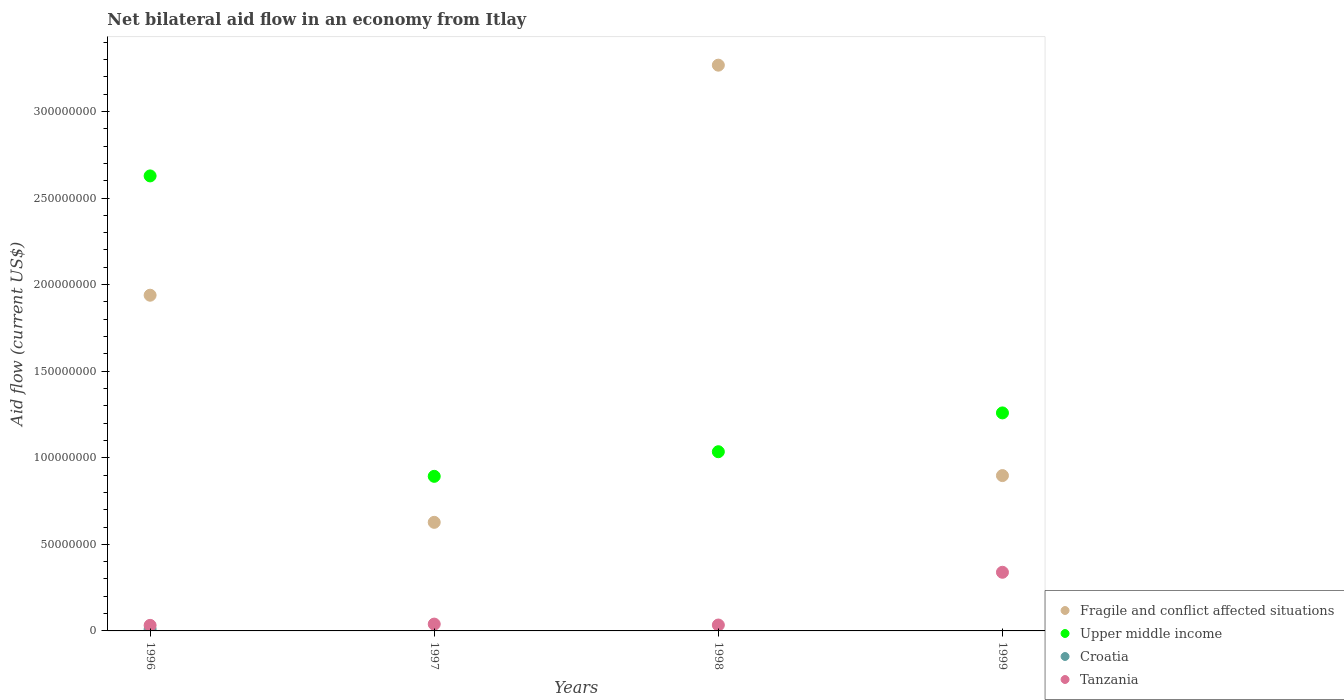What is the net bilateral aid flow in Fragile and conflict affected situations in 1999?
Your response must be concise. 8.97e+07. Across all years, what is the maximum net bilateral aid flow in Upper middle income?
Provide a succinct answer. 2.63e+08. Across all years, what is the minimum net bilateral aid flow in Upper middle income?
Ensure brevity in your answer.  8.93e+07. What is the total net bilateral aid flow in Upper middle income in the graph?
Offer a terse response. 5.81e+08. What is the difference between the net bilateral aid flow in Fragile and conflict affected situations in 1996 and that in 1997?
Your answer should be very brief. 1.31e+08. What is the difference between the net bilateral aid flow in Tanzania in 1998 and the net bilateral aid flow in Upper middle income in 1997?
Offer a terse response. -8.59e+07. What is the average net bilateral aid flow in Fragile and conflict affected situations per year?
Provide a short and direct response. 1.68e+08. In the year 1998, what is the difference between the net bilateral aid flow in Upper middle income and net bilateral aid flow in Tanzania?
Ensure brevity in your answer.  1.00e+08. In how many years, is the net bilateral aid flow in Fragile and conflict affected situations greater than 170000000 US$?
Keep it short and to the point. 2. What is the ratio of the net bilateral aid flow in Fragile and conflict affected situations in 1998 to that in 1999?
Your response must be concise. 3.64. What is the difference between the highest and the second highest net bilateral aid flow in Upper middle income?
Offer a terse response. 1.37e+08. What is the difference between the highest and the lowest net bilateral aid flow in Croatia?
Keep it short and to the point. 9.80e+05. Is the net bilateral aid flow in Tanzania strictly greater than the net bilateral aid flow in Fragile and conflict affected situations over the years?
Provide a succinct answer. No. Is the net bilateral aid flow in Croatia strictly less than the net bilateral aid flow in Tanzania over the years?
Your response must be concise. Yes. How many dotlines are there?
Give a very brief answer. 4. How many years are there in the graph?
Give a very brief answer. 4. What is the difference between two consecutive major ticks on the Y-axis?
Provide a short and direct response. 5.00e+07. Does the graph contain grids?
Your response must be concise. No. How are the legend labels stacked?
Give a very brief answer. Vertical. What is the title of the graph?
Keep it short and to the point. Net bilateral aid flow in an economy from Itlay. Does "United States" appear as one of the legend labels in the graph?
Offer a very short reply. No. What is the label or title of the Y-axis?
Give a very brief answer. Aid flow (current US$). What is the Aid flow (current US$) in Fragile and conflict affected situations in 1996?
Make the answer very short. 1.94e+08. What is the Aid flow (current US$) in Upper middle income in 1996?
Your response must be concise. 2.63e+08. What is the Aid flow (current US$) in Croatia in 1996?
Make the answer very short. 9.80e+05. What is the Aid flow (current US$) in Tanzania in 1996?
Make the answer very short. 3.21e+06. What is the Aid flow (current US$) in Fragile and conflict affected situations in 1997?
Offer a very short reply. 6.27e+07. What is the Aid flow (current US$) of Upper middle income in 1997?
Provide a short and direct response. 8.93e+07. What is the Aid flow (current US$) in Croatia in 1997?
Your answer should be very brief. 0. What is the Aid flow (current US$) of Tanzania in 1997?
Your answer should be very brief. 3.94e+06. What is the Aid flow (current US$) of Fragile and conflict affected situations in 1998?
Keep it short and to the point. 3.27e+08. What is the Aid flow (current US$) in Upper middle income in 1998?
Offer a very short reply. 1.03e+08. What is the Aid flow (current US$) of Tanzania in 1998?
Ensure brevity in your answer.  3.41e+06. What is the Aid flow (current US$) in Fragile and conflict affected situations in 1999?
Your answer should be very brief. 8.97e+07. What is the Aid flow (current US$) of Upper middle income in 1999?
Keep it short and to the point. 1.26e+08. What is the Aid flow (current US$) in Tanzania in 1999?
Offer a very short reply. 3.39e+07. Across all years, what is the maximum Aid flow (current US$) in Fragile and conflict affected situations?
Your answer should be very brief. 3.27e+08. Across all years, what is the maximum Aid flow (current US$) of Upper middle income?
Provide a short and direct response. 2.63e+08. Across all years, what is the maximum Aid flow (current US$) in Croatia?
Your response must be concise. 9.80e+05. Across all years, what is the maximum Aid flow (current US$) of Tanzania?
Make the answer very short. 3.39e+07. Across all years, what is the minimum Aid flow (current US$) of Fragile and conflict affected situations?
Provide a short and direct response. 6.27e+07. Across all years, what is the minimum Aid flow (current US$) of Upper middle income?
Your answer should be compact. 8.93e+07. Across all years, what is the minimum Aid flow (current US$) in Croatia?
Your response must be concise. 0. Across all years, what is the minimum Aid flow (current US$) of Tanzania?
Offer a terse response. 3.21e+06. What is the total Aid flow (current US$) in Fragile and conflict affected situations in the graph?
Ensure brevity in your answer.  6.73e+08. What is the total Aid flow (current US$) of Upper middle income in the graph?
Ensure brevity in your answer.  5.81e+08. What is the total Aid flow (current US$) in Croatia in the graph?
Ensure brevity in your answer.  9.80e+05. What is the total Aid flow (current US$) of Tanzania in the graph?
Provide a succinct answer. 4.44e+07. What is the difference between the Aid flow (current US$) of Fragile and conflict affected situations in 1996 and that in 1997?
Provide a succinct answer. 1.31e+08. What is the difference between the Aid flow (current US$) in Upper middle income in 1996 and that in 1997?
Your answer should be very brief. 1.74e+08. What is the difference between the Aid flow (current US$) of Tanzania in 1996 and that in 1997?
Provide a succinct answer. -7.30e+05. What is the difference between the Aid flow (current US$) of Fragile and conflict affected situations in 1996 and that in 1998?
Provide a succinct answer. -1.33e+08. What is the difference between the Aid flow (current US$) in Upper middle income in 1996 and that in 1998?
Make the answer very short. 1.59e+08. What is the difference between the Aid flow (current US$) in Fragile and conflict affected situations in 1996 and that in 1999?
Your answer should be compact. 1.04e+08. What is the difference between the Aid flow (current US$) in Upper middle income in 1996 and that in 1999?
Your response must be concise. 1.37e+08. What is the difference between the Aid flow (current US$) in Tanzania in 1996 and that in 1999?
Offer a very short reply. -3.07e+07. What is the difference between the Aid flow (current US$) of Fragile and conflict affected situations in 1997 and that in 1998?
Your answer should be very brief. -2.64e+08. What is the difference between the Aid flow (current US$) in Upper middle income in 1997 and that in 1998?
Give a very brief answer. -1.42e+07. What is the difference between the Aid flow (current US$) of Tanzania in 1997 and that in 1998?
Keep it short and to the point. 5.30e+05. What is the difference between the Aid flow (current US$) in Fragile and conflict affected situations in 1997 and that in 1999?
Provide a succinct answer. -2.70e+07. What is the difference between the Aid flow (current US$) of Upper middle income in 1997 and that in 1999?
Make the answer very short. -3.66e+07. What is the difference between the Aid flow (current US$) of Tanzania in 1997 and that in 1999?
Your response must be concise. -2.99e+07. What is the difference between the Aid flow (current US$) of Fragile and conflict affected situations in 1998 and that in 1999?
Make the answer very short. 2.37e+08. What is the difference between the Aid flow (current US$) in Upper middle income in 1998 and that in 1999?
Offer a terse response. -2.24e+07. What is the difference between the Aid flow (current US$) in Tanzania in 1998 and that in 1999?
Make the answer very short. -3.05e+07. What is the difference between the Aid flow (current US$) in Fragile and conflict affected situations in 1996 and the Aid flow (current US$) in Upper middle income in 1997?
Provide a short and direct response. 1.05e+08. What is the difference between the Aid flow (current US$) of Fragile and conflict affected situations in 1996 and the Aid flow (current US$) of Tanzania in 1997?
Provide a short and direct response. 1.90e+08. What is the difference between the Aid flow (current US$) in Upper middle income in 1996 and the Aid flow (current US$) in Tanzania in 1997?
Make the answer very short. 2.59e+08. What is the difference between the Aid flow (current US$) in Croatia in 1996 and the Aid flow (current US$) in Tanzania in 1997?
Ensure brevity in your answer.  -2.96e+06. What is the difference between the Aid flow (current US$) of Fragile and conflict affected situations in 1996 and the Aid flow (current US$) of Upper middle income in 1998?
Provide a succinct answer. 9.04e+07. What is the difference between the Aid flow (current US$) of Fragile and conflict affected situations in 1996 and the Aid flow (current US$) of Tanzania in 1998?
Your response must be concise. 1.90e+08. What is the difference between the Aid flow (current US$) of Upper middle income in 1996 and the Aid flow (current US$) of Tanzania in 1998?
Keep it short and to the point. 2.59e+08. What is the difference between the Aid flow (current US$) of Croatia in 1996 and the Aid flow (current US$) of Tanzania in 1998?
Provide a short and direct response. -2.43e+06. What is the difference between the Aid flow (current US$) in Fragile and conflict affected situations in 1996 and the Aid flow (current US$) in Upper middle income in 1999?
Your response must be concise. 6.80e+07. What is the difference between the Aid flow (current US$) of Fragile and conflict affected situations in 1996 and the Aid flow (current US$) of Tanzania in 1999?
Your answer should be compact. 1.60e+08. What is the difference between the Aid flow (current US$) in Upper middle income in 1996 and the Aid flow (current US$) in Tanzania in 1999?
Keep it short and to the point. 2.29e+08. What is the difference between the Aid flow (current US$) in Croatia in 1996 and the Aid flow (current US$) in Tanzania in 1999?
Your response must be concise. -3.29e+07. What is the difference between the Aid flow (current US$) in Fragile and conflict affected situations in 1997 and the Aid flow (current US$) in Upper middle income in 1998?
Your answer should be compact. -4.08e+07. What is the difference between the Aid flow (current US$) in Fragile and conflict affected situations in 1997 and the Aid flow (current US$) in Tanzania in 1998?
Your answer should be very brief. 5.93e+07. What is the difference between the Aid flow (current US$) in Upper middle income in 1997 and the Aid flow (current US$) in Tanzania in 1998?
Make the answer very short. 8.59e+07. What is the difference between the Aid flow (current US$) in Fragile and conflict affected situations in 1997 and the Aid flow (current US$) in Upper middle income in 1999?
Offer a very short reply. -6.32e+07. What is the difference between the Aid flow (current US$) in Fragile and conflict affected situations in 1997 and the Aid flow (current US$) in Tanzania in 1999?
Keep it short and to the point. 2.88e+07. What is the difference between the Aid flow (current US$) of Upper middle income in 1997 and the Aid flow (current US$) of Tanzania in 1999?
Give a very brief answer. 5.54e+07. What is the difference between the Aid flow (current US$) in Fragile and conflict affected situations in 1998 and the Aid flow (current US$) in Upper middle income in 1999?
Give a very brief answer. 2.01e+08. What is the difference between the Aid flow (current US$) of Fragile and conflict affected situations in 1998 and the Aid flow (current US$) of Tanzania in 1999?
Keep it short and to the point. 2.93e+08. What is the difference between the Aid flow (current US$) in Upper middle income in 1998 and the Aid flow (current US$) in Tanzania in 1999?
Offer a terse response. 6.96e+07. What is the average Aid flow (current US$) of Fragile and conflict affected situations per year?
Your answer should be compact. 1.68e+08. What is the average Aid flow (current US$) of Upper middle income per year?
Offer a terse response. 1.45e+08. What is the average Aid flow (current US$) of Croatia per year?
Keep it short and to the point. 2.45e+05. What is the average Aid flow (current US$) of Tanzania per year?
Ensure brevity in your answer.  1.11e+07. In the year 1996, what is the difference between the Aid flow (current US$) of Fragile and conflict affected situations and Aid flow (current US$) of Upper middle income?
Provide a succinct answer. -6.89e+07. In the year 1996, what is the difference between the Aid flow (current US$) of Fragile and conflict affected situations and Aid flow (current US$) of Croatia?
Give a very brief answer. 1.93e+08. In the year 1996, what is the difference between the Aid flow (current US$) in Fragile and conflict affected situations and Aid flow (current US$) in Tanzania?
Offer a terse response. 1.91e+08. In the year 1996, what is the difference between the Aid flow (current US$) of Upper middle income and Aid flow (current US$) of Croatia?
Your answer should be compact. 2.62e+08. In the year 1996, what is the difference between the Aid flow (current US$) of Upper middle income and Aid flow (current US$) of Tanzania?
Offer a very short reply. 2.60e+08. In the year 1996, what is the difference between the Aid flow (current US$) of Croatia and Aid flow (current US$) of Tanzania?
Your answer should be compact. -2.23e+06. In the year 1997, what is the difference between the Aid flow (current US$) of Fragile and conflict affected situations and Aid flow (current US$) of Upper middle income?
Provide a short and direct response. -2.66e+07. In the year 1997, what is the difference between the Aid flow (current US$) of Fragile and conflict affected situations and Aid flow (current US$) of Tanzania?
Provide a short and direct response. 5.88e+07. In the year 1997, what is the difference between the Aid flow (current US$) in Upper middle income and Aid flow (current US$) in Tanzania?
Your response must be concise. 8.53e+07. In the year 1998, what is the difference between the Aid flow (current US$) of Fragile and conflict affected situations and Aid flow (current US$) of Upper middle income?
Provide a succinct answer. 2.23e+08. In the year 1998, what is the difference between the Aid flow (current US$) in Fragile and conflict affected situations and Aid flow (current US$) in Tanzania?
Keep it short and to the point. 3.23e+08. In the year 1998, what is the difference between the Aid flow (current US$) of Upper middle income and Aid flow (current US$) of Tanzania?
Offer a terse response. 1.00e+08. In the year 1999, what is the difference between the Aid flow (current US$) in Fragile and conflict affected situations and Aid flow (current US$) in Upper middle income?
Offer a terse response. -3.62e+07. In the year 1999, what is the difference between the Aid flow (current US$) in Fragile and conflict affected situations and Aid flow (current US$) in Tanzania?
Your response must be concise. 5.58e+07. In the year 1999, what is the difference between the Aid flow (current US$) in Upper middle income and Aid flow (current US$) in Tanzania?
Ensure brevity in your answer.  9.20e+07. What is the ratio of the Aid flow (current US$) in Fragile and conflict affected situations in 1996 to that in 1997?
Give a very brief answer. 3.09. What is the ratio of the Aid flow (current US$) of Upper middle income in 1996 to that in 1997?
Give a very brief answer. 2.94. What is the ratio of the Aid flow (current US$) in Tanzania in 1996 to that in 1997?
Your response must be concise. 0.81. What is the ratio of the Aid flow (current US$) in Fragile and conflict affected situations in 1996 to that in 1998?
Keep it short and to the point. 0.59. What is the ratio of the Aid flow (current US$) of Upper middle income in 1996 to that in 1998?
Your response must be concise. 2.54. What is the ratio of the Aid flow (current US$) in Tanzania in 1996 to that in 1998?
Offer a terse response. 0.94. What is the ratio of the Aid flow (current US$) in Fragile and conflict affected situations in 1996 to that in 1999?
Offer a very short reply. 2.16. What is the ratio of the Aid flow (current US$) in Upper middle income in 1996 to that in 1999?
Your answer should be compact. 2.09. What is the ratio of the Aid flow (current US$) in Tanzania in 1996 to that in 1999?
Your answer should be compact. 0.09. What is the ratio of the Aid flow (current US$) of Fragile and conflict affected situations in 1997 to that in 1998?
Provide a succinct answer. 0.19. What is the ratio of the Aid flow (current US$) of Upper middle income in 1997 to that in 1998?
Keep it short and to the point. 0.86. What is the ratio of the Aid flow (current US$) of Tanzania in 1997 to that in 1998?
Your answer should be very brief. 1.16. What is the ratio of the Aid flow (current US$) of Fragile and conflict affected situations in 1997 to that in 1999?
Your response must be concise. 0.7. What is the ratio of the Aid flow (current US$) of Upper middle income in 1997 to that in 1999?
Provide a succinct answer. 0.71. What is the ratio of the Aid flow (current US$) of Tanzania in 1997 to that in 1999?
Your answer should be very brief. 0.12. What is the ratio of the Aid flow (current US$) in Fragile and conflict affected situations in 1998 to that in 1999?
Keep it short and to the point. 3.64. What is the ratio of the Aid flow (current US$) of Upper middle income in 1998 to that in 1999?
Offer a very short reply. 0.82. What is the ratio of the Aid flow (current US$) in Tanzania in 1998 to that in 1999?
Offer a terse response. 0.1. What is the difference between the highest and the second highest Aid flow (current US$) of Fragile and conflict affected situations?
Your response must be concise. 1.33e+08. What is the difference between the highest and the second highest Aid flow (current US$) in Upper middle income?
Your answer should be compact. 1.37e+08. What is the difference between the highest and the second highest Aid flow (current US$) in Tanzania?
Offer a terse response. 2.99e+07. What is the difference between the highest and the lowest Aid flow (current US$) of Fragile and conflict affected situations?
Provide a succinct answer. 2.64e+08. What is the difference between the highest and the lowest Aid flow (current US$) of Upper middle income?
Your answer should be compact. 1.74e+08. What is the difference between the highest and the lowest Aid flow (current US$) in Croatia?
Keep it short and to the point. 9.80e+05. What is the difference between the highest and the lowest Aid flow (current US$) of Tanzania?
Offer a very short reply. 3.07e+07. 